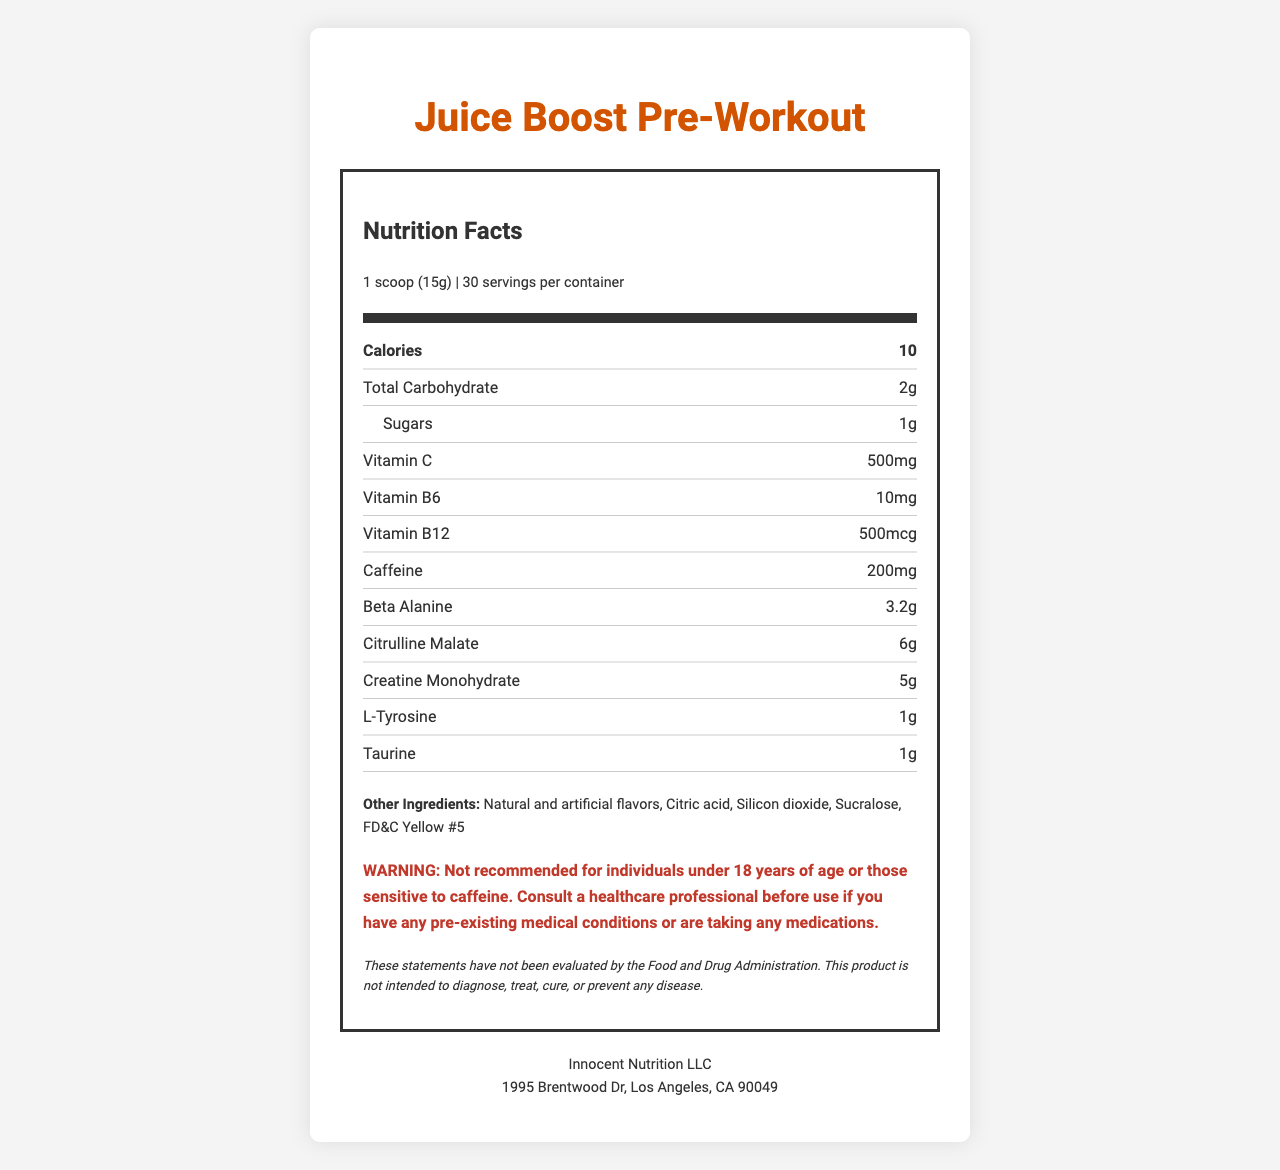what is the serving size? The serving size is specified as "1 scoop (15g)" in the document.
Answer: 1 scoop (15g) how many servings are there per container? The document states that there are 30 servings per container.
Answer: 30 what is the total carbohydrate content per serving? The nutrition facts label indicates that there are 2g of total carbohydrates per serving.
Answer: 2g how much caffeine is in each serving? Each serving contains 200mg of caffeine as specified in the document.
Answer: 200mg what is the flavor of the supplement? The flavor is mentioned as "Orange Bronco."
Answer: Orange Bronco which vitamin has the highest content in this supplement? The supplement contains 500mg of Vitamin C, which is the highest among the listed vitamins.
Answer: Vitamin C what warning is provided for individuals under a certain age? A. Not recommended for those over 18 B. Not recommended for those under 18 C. Not recommended for children D. Not recommended for athletes The warning specifies that the supplement is not recommended for individuals under 18 years of age.
Answer: B what are some of the other ingredients in this product? A. Natural and artificial colors B. Citric acid C. Ascorbic acid D. B vitamins Citric acid is listed as one of the other ingredients in the supplement.
Answer: B is this product suitable for someone allergic to peanuts? The allergen information states that the product is manufactured in a facility that processes peanuts, making it unsuitable for someone with a peanut allergy.
Answer: No what should be done 20-30 minutes before a workout according to the directions? The directions indicate to mix 1 scoop with 8-10 oz of cold water and consume 20-30 minutes before the workout.
Answer: Mix 1 scoop with 8-10 oz of cold water summarize the main nutritional components of this pre-workout supplement. The document details the serving size, nutritional breakdown, key ingredients, and other components designed to increase energy and focus for workouts.
Answer: Juice Boost Pre-Workout includes calories (10), carbohydrates (2g), sugars (1g), vitamins (Vitamin C - 500mg, Vitamin B6 - 10mg, Vitamin B12 - 500mcg), and energy-boosting ingredients (caffeine - 200mg, beta-alanine - 3.2g, citrulline malate - 6g, creatine monohydrate - 5g, L-Tyrosine - 1g, taurine - 1g). Other ingredients include natural and artificial flavors, citric acid, silicon dioxide, sucralose, and FD&C Yellow #5. what is the total creatine monohydrate content per serving? The document specifies that there are 5g of creatine monohydrate in each serving.
Answer: 5g does this product cure or prevent diseases? The disclaimer states that the product is not intended to diagnose, treat, cure, or prevent any disease.
Answer: No who manufactures Juice Boost Pre-Workout? The manufacturer listed on the document is Innocent Nutrition LLC.
Answer: Innocent Nutrition LLC what is the address of the manufacturer? The address of the manufacturer is provided in the document.
Answer: 1995 Brentwood Dr, Los Angeles, CA 90049 what effect does the supplement promise to have? The supplement promises to increase energy and focus, as deduced from the product description.
Answer: Increased energy and focus what is the ratio of beta-alanine to citrulline malate in the supplement? The document provides the individual quantities but does not specify a ratio between beta-alanine and citrulline malate.
Answer: Cannot be determined 